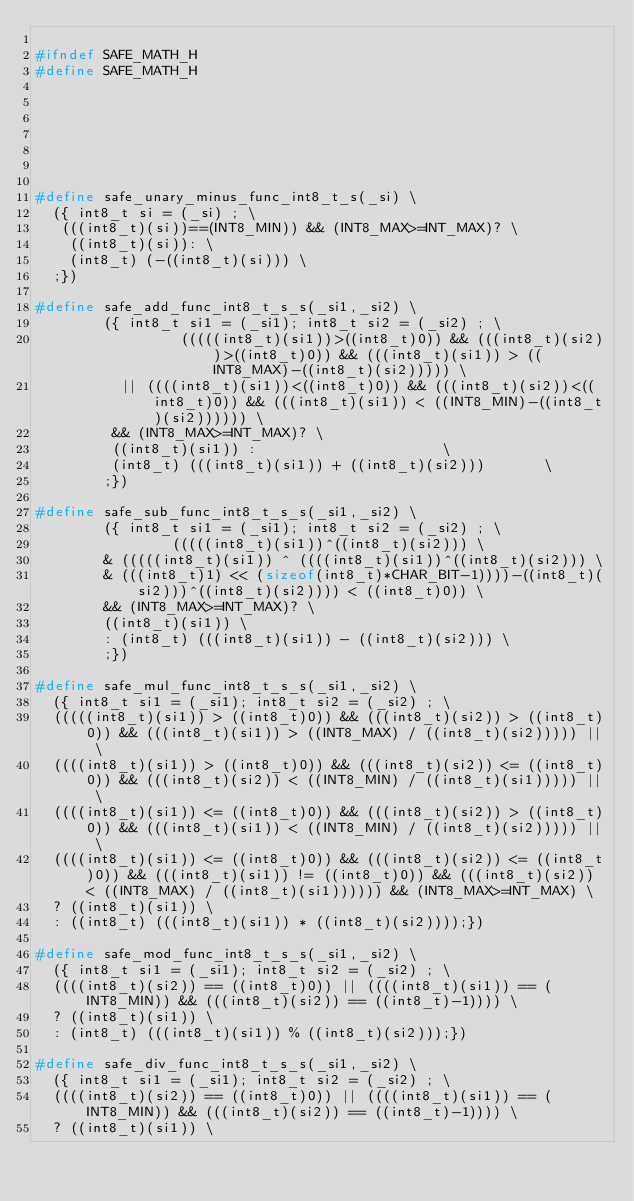Convert code to text. <code><loc_0><loc_0><loc_500><loc_500><_C_>
#ifndef SAFE_MATH_H
#define SAFE_MATH_H







#define safe_unary_minus_func_int8_t_s(_si) \
  ({ int8_t si = (_si) ; \
   (((int8_t)(si))==(INT8_MIN)) && (INT8_MAX>=INT_MAX)? \
    ((int8_t)(si)): \
    (int8_t) (-((int8_t)(si))) \
  ;})

#define safe_add_func_int8_t_s_s(_si1,_si2) \
		({ int8_t si1 = (_si1); int8_t si2 = (_si2) ; \
                 (((((int8_t)(si1))>((int8_t)0)) && (((int8_t)(si2))>((int8_t)0)) && (((int8_t)(si1)) > ((INT8_MAX)-((int8_t)(si2))))) \
		  || ((((int8_t)(si1))<((int8_t)0)) && (((int8_t)(si2))<((int8_t)0)) && (((int8_t)(si1)) < ((INT8_MIN)-((int8_t)(si2)))))) \
		 && (INT8_MAX>=INT_MAX)? \
		 ((int8_t)(si1)) :						\
		 (int8_t) (((int8_t)(si1)) + ((int8_t)(si2)))		\
		;}) 

#define safe_sub_func_int8_t_s_s(_si1,_si2) \
		({ int8_t si1 = (_si1); int8_t si2 = (_si2) ; \
                (((((int8_t)(si1))^((int8_t)(si2))) \
		& (((((int8_t)(si1)) ^ ((((int8_t)(si1))^((int8_t)(si2))) \
		& (((int8_t)1) << (sizeof(int8_t)*CHAR_BIT-1))))-((int8_t)(si2)))^((int8_t)(si2)))) < ((int8_t)0)) \
		&& (INT8_MAX>=INT_MAX)? \
		((int8_t)(si1)) \
		: (int8_t) (((int8_t)(si1)) - ((int8_t)(si2))) \
		;})

#define safe_mul_func_int8_t_s_s(_si1,_si2) \
  ({ int8_t si1 = (_si1); int8_t si2 = (_si2) ; \
  (((((int8_t)(si1)) > ((int8_t)0)) && (((int8_t)(si2)) > ((int8_t)0)) && (((int8_t)(si1)) > ((INT8_MAX) / ((int8_t)(si2))))) || \
  ((((int8_t)(si1)) > ((int8_t)0)) && (((int8_t)(si2)) <= ((int8_t)0)) && (((int8_t)(si2)) < ((INT8_MIN) / ((int8_t)(si1))))) || \
  ((((int8_t)(si1)) <= ((int8_t)0)) && (((int8_t)(si2)) > ((int8_t)0)) && (((int8_t)(si1)) < ((INT8_MIN) / ((int8_t)(si2))))) || \
  ((((int8_t)(si1)) <= ((int8_t)0)) && (((int8_t)(si2)) <= ((int8_t)0)) && (((int8_t)(si1)) != ((int8_t)0)) && (((int8_t)(si2)) < ((INT8_MAX) / ((int8_t)(si1)))))) && (INT8_MAX>=INT_MAX) \
  ? ((int8_t)(si1)) \
  : ((int8_t) (((int8_t)(si1)) * ((int8_t)(si2))));})

#define safe_mod_func_int8_t_s_s(_si1,_si2) \
  ({ int8_t si1 = (_si1); int8_t si2 = (_si2) ; \
  ((((int8_t)(si2)) == ((int8_t)0)) || ((((int8_t)(si1)) == (INT8_MIN)) && (((int8_t)(si2)) == ((int8_t)-1)))) \
  ? ((int8_t)(si1)) \
  : (int8_t) (((int8_t)(si1)) % ((int8_t)(si2)));})

#define safe_div_func_int8_t_s_s(_si1,_si2) \
  ({ int8_t si1 = (_si1); int8_t si2 = (_si2) ; \
  ((((int8_t)(si2)) == ((int8_t)0)) || ((((int8_t)(si1)) == (INT8_MIN)) && (((int8_t)(si2)) == ((int8_t)-1)))) \
  ? ((int8_t)(si1)) \</code> 